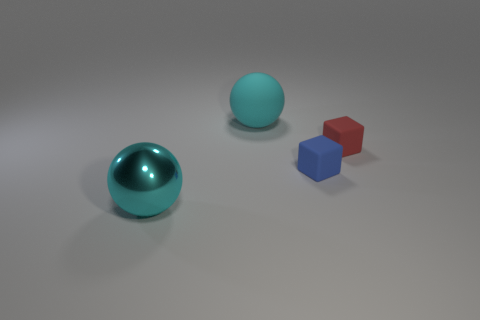There is another thing that is the same color as the shiny object; what material is it?
Your answer should be compact. Rubber. Is the number of large cyan objects left of the cyan shiny ball less than the number of big red cylinders?
Keep it short and to the point. No. What is the shape of the object that is the same size as the matte ball?
Ensure brevity in your answer.  Sphere. Do the red rubber object and the blue thing have the same size?
Make the answer very short. Yes. How many things are either big shiny balls or rubber things that are in front of the small red rubber cube?
Ensure brevity in your answer.  2. Are there fewer cyan balls that are behind the red cube than blue cubes right of the blue thing?
Provide a short and direct response. No. Does the tiny thing in front of the red rubber block have the same color as the big shiny object?
Provide a succinct answer. No. Are there any large objects that are to the right of the big cyan object that is to the left of the cyan matte sphere?
Ensure brevity in your answer.  Yes. What material is the thing that is both left of the small blue cube and in front of the small red object?
Your response must be concise. Metal. What is the shape of the small object that is the same material as the red cube?
Your answer should be compact. Cube. 